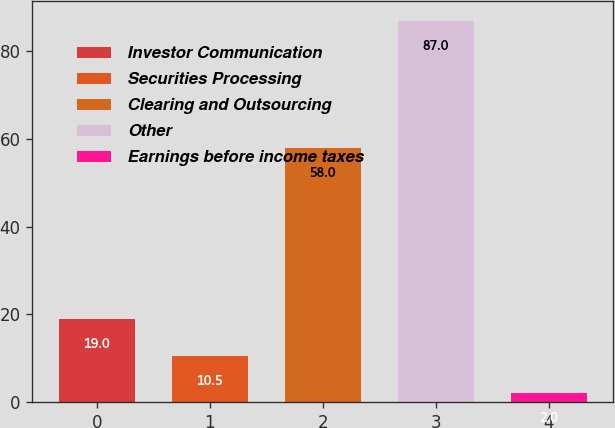<chart> <loc_0><loc_0><loc_500><loc_500><bar_chart><fcel>Investor Communication<fcel>Securities Processing<fcel>Clearing and Outsourcing<fcel>Other<fcel>Earnings before income taxes<nl><fcel>19<fcel>10.5<fcel>58<fcel>87<fcel>2<nl></chart> 